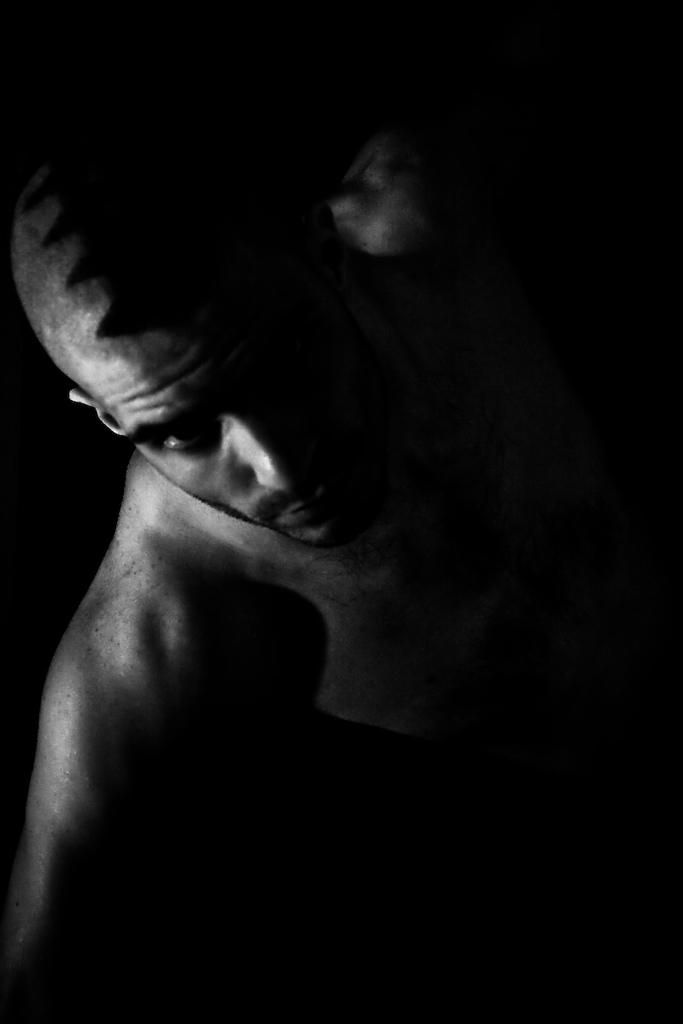What is present in the image? There is a man in the image. What is the color of the background in the image? The background of the image is black. Can you see any tickets being used by the man in the image? There is no mention of tickets in the image, so it cannot be determined if the man is using any tickets. Are there any bubbles visible in the image? There is no mention of bubbles in the image, so it cannot be determined if any bubbles are present. 